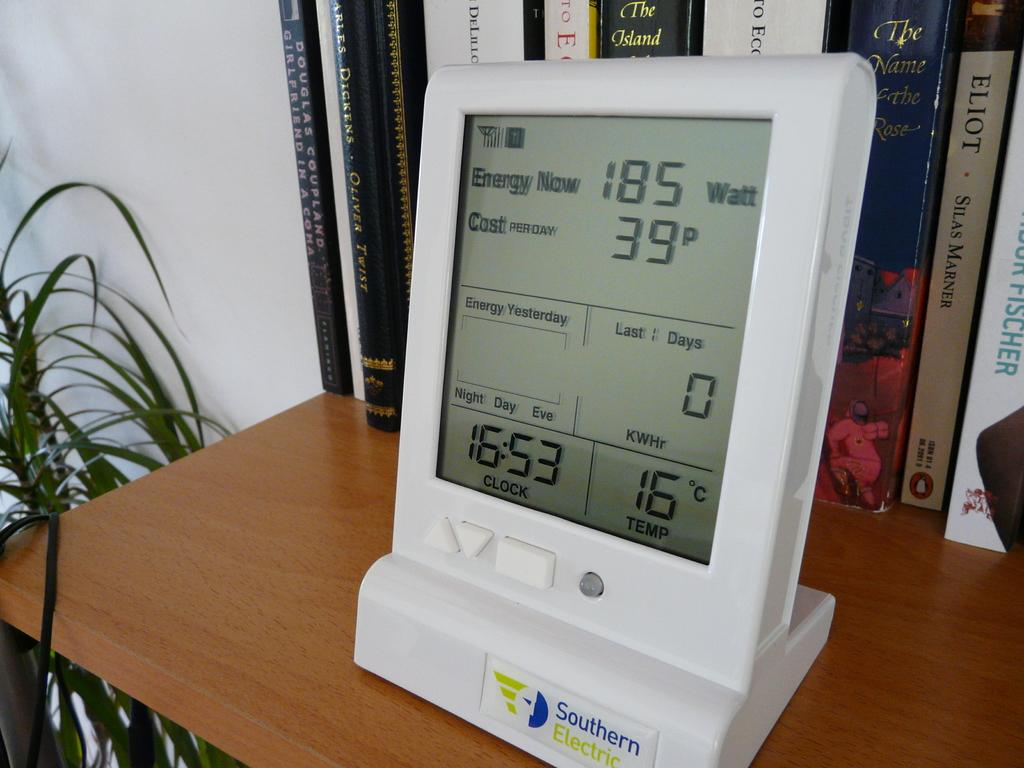Provide a one-sentence caption for the provided image. A Southern Electric Energy Meter sits on top of a desk in front of a bookshelf. 